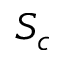Convert formula to latex. <formula><loc_0><loc_0><loc_500><loc_500>S _ { c }</formula> 